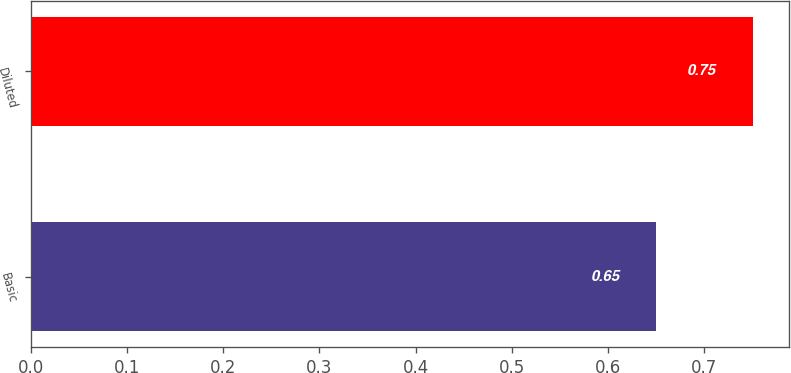Convert chart. <chart><loc_0><loc_0><loc_500><loc_500><bar_chart><fcel>Basic<fcel>Diluted<nl><fcel>0.65<fcel>0.75<nl></chart> 